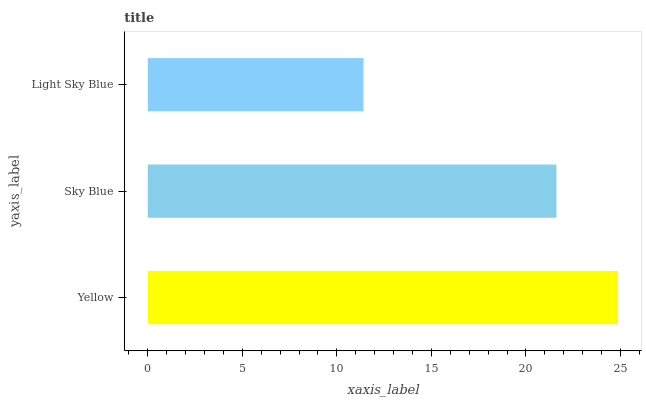Is Light Sky Blue the minimum?
Answer yes or no. Yes. Is Yellow the maximum?
Answer yes or no. Yes. Is Sky Blue the minimum?
Answer yes or no. No. Is Sky Blue the maximum?
Answer yes or no. No. Is Yellow greater than Sky Blue?
Answer yes or no. Yes. Is Sky Blue less than Yellow?
Answer yes or no. Yes. Is Sky Blue greater than Yellow?
Answer yes or no. No. Is Yellow less than Sky Blue?
Answer yes or no. No. Is Sky Blue the high median?
Answer yes or no. Yes. Is Sky Blue the low median?
Answer yes or no. Yes. Is Yellow the high median?
Answer yes or no. No. Is Light Sky Blue the low median?
Answer yes or no. No. 